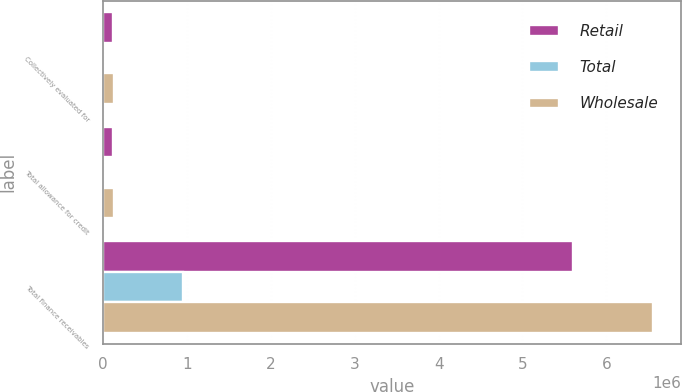Convert chart to OTSL. <chart><loc_0><loc_0><loc_500><loc_500><stacked_bar_chart><ecel><fcel>Collectively evaluated for<fcel>Total allowance for credit<fcel>Total finance receivables<nl><fcel>Retail<fcel>122025<fcel>122025<fcel>5.60792e+06<nl><fcel>Total<fcel>5339<fcel>5339<fcel>952321<nl><fcel>Wholesale<fcel>127364<fcel>127364<fcel>6.56024e+06<nl></chart> 